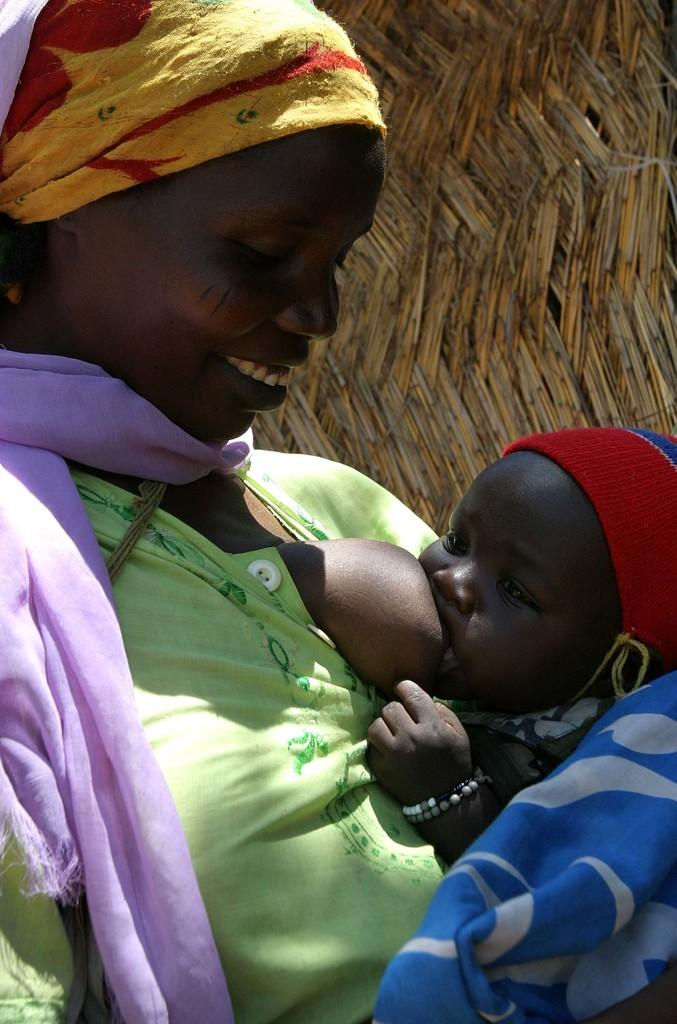Who is present in the image? There is a woman and a baby in the image. What is the woman wearing? The woman is wearing a dress with green, purple, yellow, and red colors. What color is the background of the image? The background of the image is brown. What type of prose can be heard in the background of the image? There is no prose or sound present in the image; it is a still photograph. 